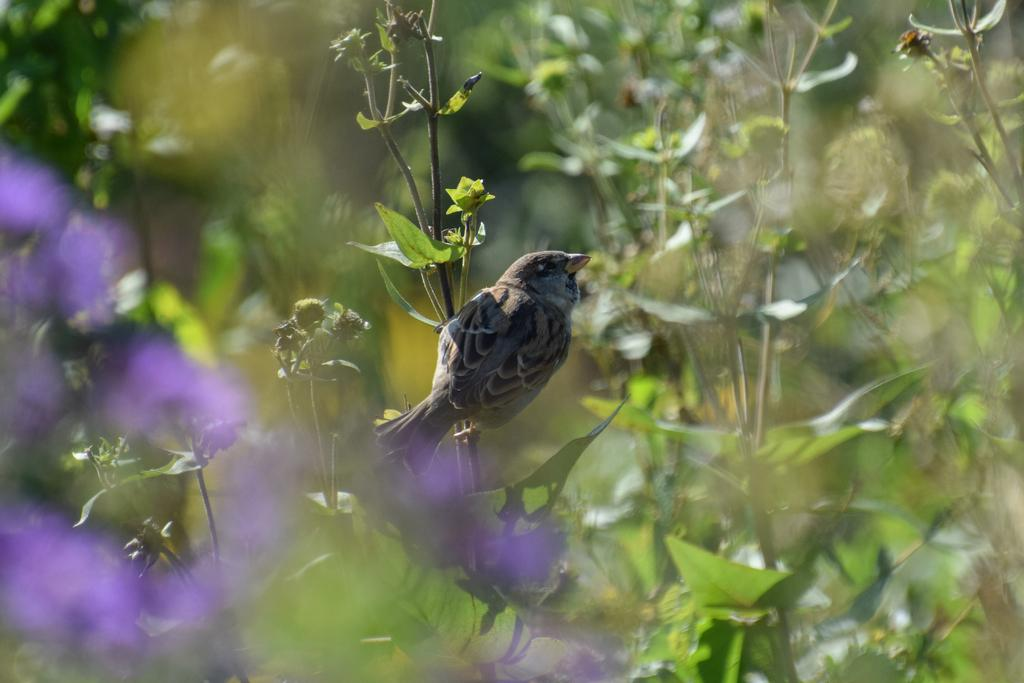What is the quality of the image in the front? The image is blurred in the front. What can be seen sitting on a plant in the image? There is a bird sitting on a plant in the image. What type of vegetation is visible in the background? There are plants visible in the background. What type of stick can be seen being used by the bird in the image? There is no stick present in the image, nor is the bird using any tool. 